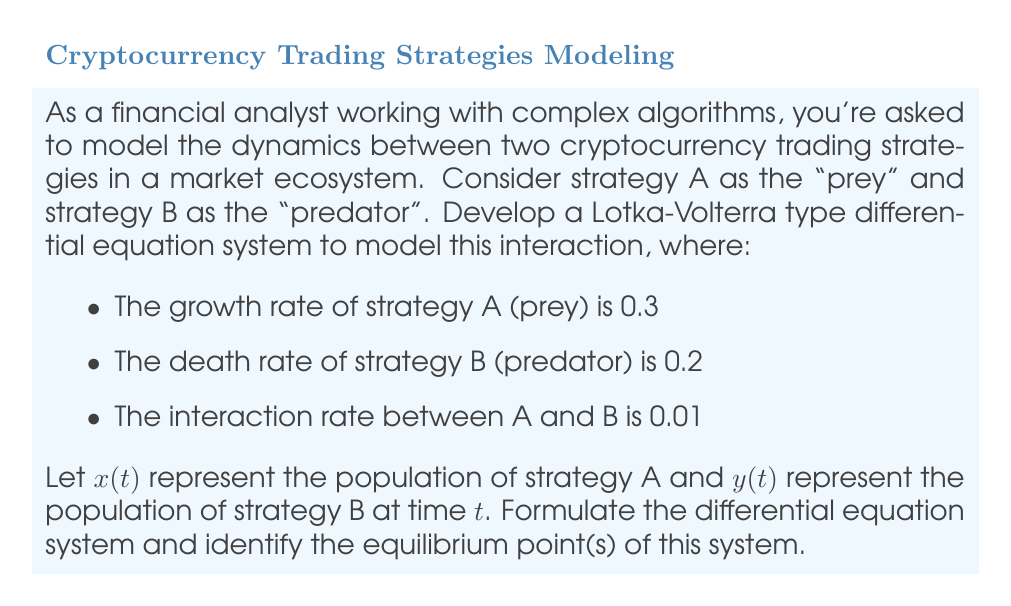What is the answer to this math problem? To model this predator-prey dynamics using a Lotka-Volterra type system, we need to set up two differential equations:

1) For the prey (strategy A):
   $$\frac{dx}{dt} = ax - bxy$$
   where $a$ is the growth rate of A, and $b$ is the interaction rate.

2) For the predator (strategy B):
   $$\frac{dy}{dt} = -cy + dxy$$
   where $c$ is the death rate of B, and $d$ is the interaction rate.

Given the parameters:
- Growth rate of A (a) = 0.3
- Death rate of B (c) = 0.2
- Interaction rate (b = d) = 0.01

We can now write our system:

$$\begin{cases}
\frac{dx}{dt} = 0.3x - 0.01xy \\
\frac{dy}{dt} = -0.2y + 0.01xy
\end{cases}$$

To find the equilibrium points, we set both equations to zero and solve:

$$\begin{cases}
0.3x - 0.01xy = 0 \\
-0.2y + 0.01xy = 0
\end{cases}$$

From the first equation:
$x(0.3 - 0.01y) = 0$, so either $x = 0$ or $y = 30$

From the second equation:
$y(-0.2 + 0.01x) = 0$, so either $y = 0$ or $x = 20$

Combining these results, we get two equilibrium points:
1) (0, 0): Trivial equilibrium where both populations are extinct
2) (20, 30): Non-trivial equilibrium where both populations coexist
Answer: The Lotka-Volterra differential equation system for this scenario is:

$$\begin{cases}
\frac{dx}{dt} = 0.3x - 0.01xy \\
\frac{dy}{dt} = -0.2y + 0.01xy
\end{cases}$$

The equilibrium points are (0, 0) and (20, 30). 